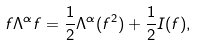Convert formula to latex. <formula><loc_0><loc_0><loc_500><loc_500>f \Lambda ^ { \alpha } f = \frac { 1 } { 2 } \Lambda ^ { \alpha } ( f ^ { 2 } ) + \frac { 1 } { 2 } I ( f ) ,</formula> 